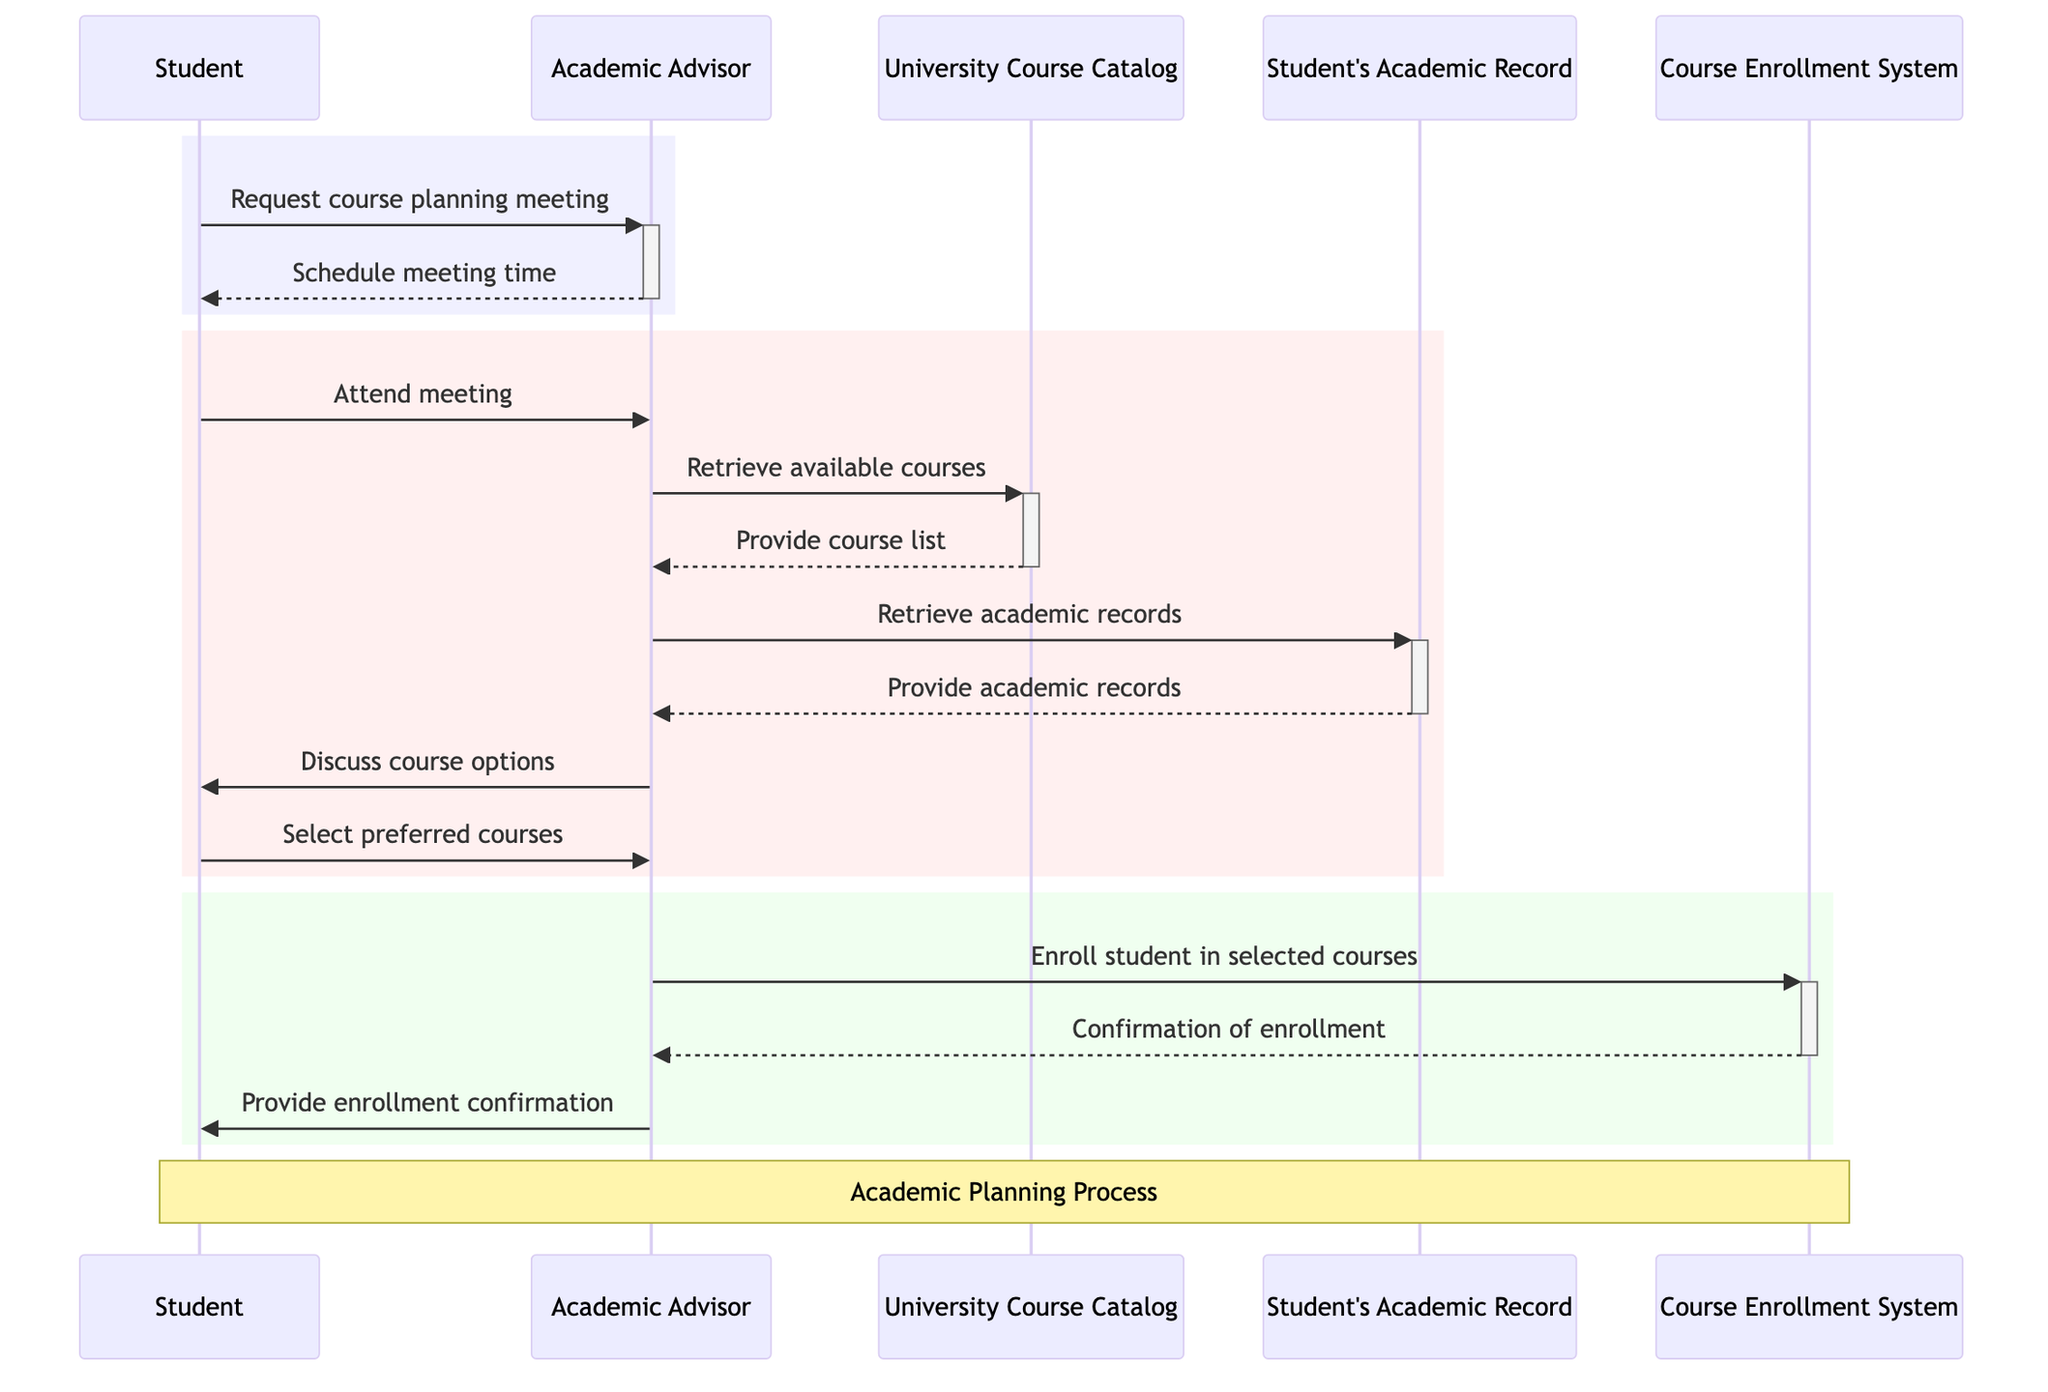What does the student request from the academic advisor? The first message from the Student to the Academic Advisor states "Request course planning meeting", indicating that the Student's initial action is to request this meeting.
Answer: course planning meeting How many main actors are involved in the sequence diagram? The diagram identifies three main actors: Student, Academic Advisor, and Academic Professor. Counting them gives a total of three actors.
Answer: three What is the last communication from the academic advisor to the student? The final message shown in the diagram comes from the Academic Advisor to the Student, stating "Provide enrollment confirmation", which is the last interaction.
Answer: Provide enrollment confirmation From whom does the academic advisor retrieve available courses? The Academic Advisor retrieves available courses from the University Course Catalog, as evidenced by the message "Retrieve available courses" directed toward this object.
Answer: University Course Catalog What is the academic advisor's first action in the meeting process? In the sequence of interactions, after receiving a request from the Student, the Academic Advisor's first action is to "Schedule meeting time". This is the first concrete step taken after the request.
Answer: Schedule meeting time How many retrieval actions does the academic advisor perform? The Academic Advisor performs two retrieval actions: one for available courses from the University Course Catalog and another for academic records from Student's Academic Record. Counting these actions results in a total of two.
Answer: two What does the enrollment confirmation signify in this context? The enrollment confirmation indicates that the Student has successfully enrolled in the selected courses, which is confirmed through the communication from the Course Enrollment System back to the Academic Advisor and subsequently to the Student.
Answer: successful enrollment Which system does the academic advisor use to enroll the student? The academic advisor uses the Course Enrollment System, as indicated by the message "Enroll student in selected courses". This specifies the system through which enrollment occurs.
Answer: Course Enrollment System What does the student do after the academic advisor provides options? After the academic advisor discusses course options, the Student selects their preferred courses, which is the immediate next action indicated in the sequence of the diagram.
Answer: Select preferred courses 